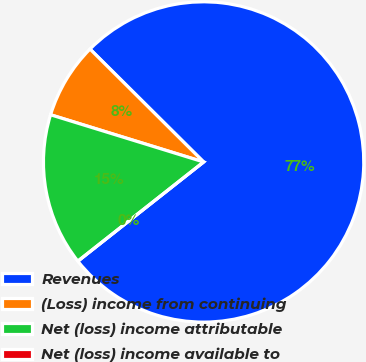Convert chart to OTSL. <chart><loc_0><loc_0><loc_500><loc_500><pie_chart><fcel>Revenues<fcel>(Loss) income from continuing<fcel>Net (loss) income attributable<fcel>Net (loss) income available to<nl><fcel>76.92%<fcel>7.69%<fcel>15.39%<fcel>0.0%<nl></chart> 